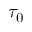Convert formula to latex. <formula><loc_0><loc_0><loc_500><loc_500>\tau _ { 0 }</formula> 